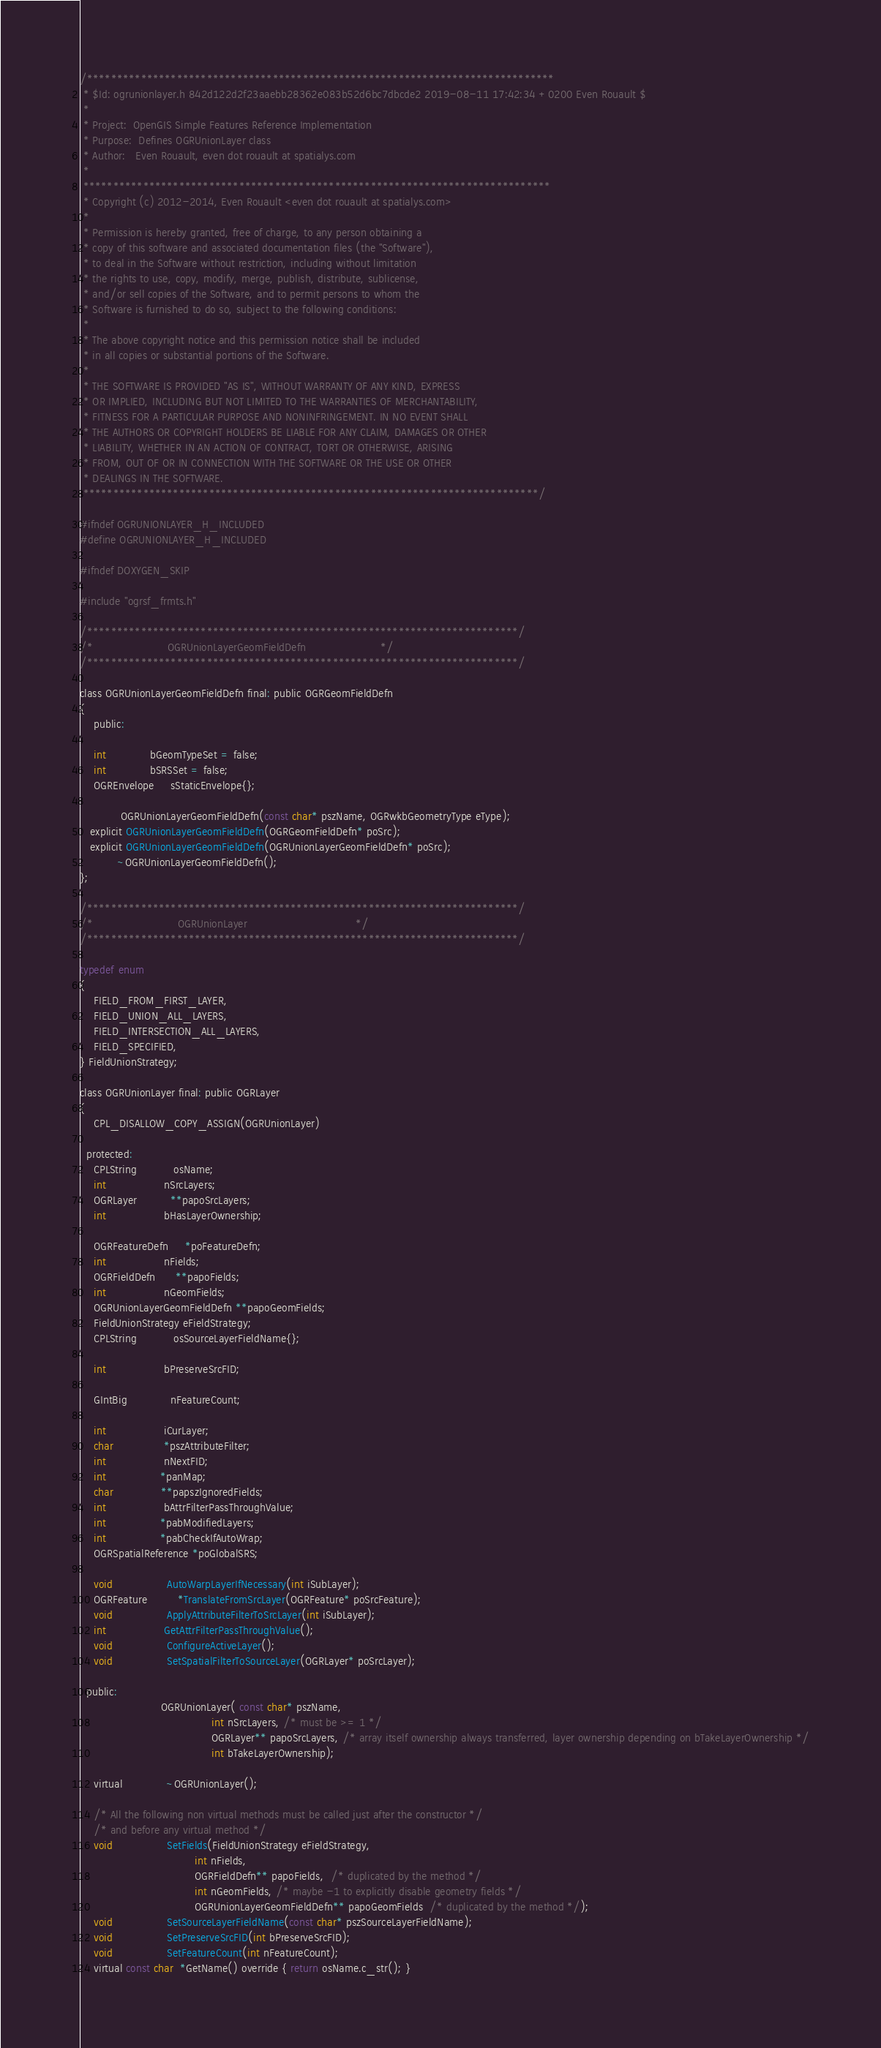<code> <loc_0><loc_0><loc_500><loc_500><_C_>/******************************************************************************
 * $Id: ogrunionlayer.h 842d122d2f23aaebb28362e083b52d6bc7dbcde2 2019-08-11 17:42:34 +0200 Even Rouault $
 *
 * Project:  OpenGIS Simple Features Reference Implementation
 * Purpose:  Defines OGRUnionLayer class
 * Author:   Even Rouault, even dot rouault at spatialys.com
 *
 ******************************************************************************
 * Copyright (c) 2012-2014, Even Rouault <even dot rouault at spatialys.com>
 *
 * Permission is hereby granted, free of charge, to any person obtaining a
 * copy of this software and associated documentation files (the "Software"),
 * to deal in the Software without restriction, including without limitation
 * the rights to use, copy, modify, merge, publish, distribute, sublicense,
 * and/or sell copies of the Software, and to permit persons to whom the
 * Software is furnished to do so, subject to the following conditions:
 *
 * The above copyright notice and this permission notice shall be included
 * in all copies or substantial portions of the Software.
 *
 * THE SOFTWARE IS PROVIDED "AS IS", WITHOUT WARRANTY OF ANY KIND, EXPRESS
 * OR IMPLIED, INCLUDING BUT NOT LIMITED TO THE WARRANTIES OF MERCHANTABILITY,
 * FITNESS FOR A PARTICULAR PURPOSE AND NONINFRINGEMENT. IN NO EVENT SHALL
 * THE AUTHORS OR COPYRIGHT HOLDERS BE LIABLE FOR ANY CLAIM, DAMAGES OR OTHER
 * LIABILITY, WHETHER IN AN ACTION OF CONTRACT, TORT OR OTHERWISE, ARISING
 * FROM, OUT OF OR IN CONNECTION WITH THE SOFTWARE OR THE USE OR OTHER
 * DEALINGS IN THE SOFTWARE.
 ****************************************************************************/

#ifndef OGRUNIONLAYER_H_INCLUDED
#define OGRUNIONLAYER_H_INCLUDED

#ifndef DOXYGEN_SKIP

#include "ogrsf_frmts.h"

/************************************************************************/
/*                      OGRUnionLayerGeomFieldDefn                      */
/************************************************************************/

class OGRUnionLayerGeomFieldDefn final: public OGRGeomFieldDefn
{
    public:

    int             bGeomTypeSet = false;
    int             bSRSSet = false;
    OGREnvelope     sStaticEnvelope{};

            OGRUnionLayerGeomFieldDefn(const char* pszName, OGRwkbGeometryType eType);
   explicit OGRUnionLayerGeomFieldDefn(OGRGeomFieldDefn* poSrc);
   explicit OGRUnionLayerGeomFieldDefn(OGRUnionLayerGeomFieldDefn* poSrc);
           ~OGRUnionLayerGeomFieldDefn();
};

/************************************************************************/
/*                         OGRUnionLayer                                */
/************************************************************************/

typedef enum
{
    FIELD_FROM_FIRST_LAYER,
    FIELD_UNION_ALL_LAYERS,
    FIELD_INTERSECTION_ALL_LAYERS,
    FIELD_SPECIFIED,
} FieldUnionStrategy;

class OGRUnionLayer final: public OGRLayer
{
    CPL_DISALLOW_COPY_ASSIGN(OGRUnionLayer)

  protected:
    CPLString           osName;
    int                 nSrcLayers;
    OGRLayer          **papoSrcLayers;
    int                 bHasLayerOwnership;

    OGRFeatureDefn     *poFeatureDefn;
    int                 nFields;
    OGRFieldDefn      **papoFields;
    int                 nGeomFields;
    OGRUnionLayerGeomFieldDefn **papoGeomFields;
    FieldUnionStrategy eFieldStrategy;
    CPLString           osSourceLayerFieldName{};

    int                 bPreserveSrcFID;

    GIntBig             nFeatureCount;

    int                 iCurLayer;
    char               *pszAttributeFilter;
    int                 nNextFID;
    int                *panMap;
    char              **papszIgnoredFields;
    int                 bAttrFilterPassThroughValue;
    int                *pabModifiedLayers;
    int                *pabCheckIfAutoWrap;
    OGRSpatialReference *poGlobalSRS;

    void                AutoWarpLayerIfNecessary(int iSubLayer);
    OGRFeature         *TranslateFromSrcLayer(OGRFeature* poSrcFeature);
    void                ApplyAttributeFilterToSrcLayer(int iSubLayer);
    int                 GetAttrFilterPassThroughValue();
    void                ConfigureActiveLayer();
    void                SetSpatialFilterToSourceLayer(OGRLayer* poSrcLayer);

  public:
                        OGRUnionLayer( const char* pszName,
                                       int nSrcLayers, /* must be >= 1 */
                                       OGRLayer** papoSrcLayers, /* array itself ownership always transferred, layer ownership depending on bTakeLayerOwnership */
                                       int bTakeLayerOwnership);

    virtual             ~OGRUnionLayer();

    /* All the following non virtual methods must be called just after the constructor */
    /* and before any virtual method */
    void                SetFields(FieldUnionStrategy eFieldStrategy,
                                  int nFields,
                                  OGRFieldDefn** papoFields,  /* duplicated by the method */
                                  int nGeomFields, /* maybe -1 to explicitly disable geometry fields */
                                  OGRUnionLayerGeomFieldDefn** papoGeomFields  /* duplicated by the method */);
    void                SetSourceLayerFieldName(const char* pszSourceLayerFieldName);
    void                SetPreserveSrcFID(int bPreserveSrcFID);
    void                SetFeatureCount(int nFeatureCount);
    virtual const char  *GetName() override { return osName.c_str(); }</code> 